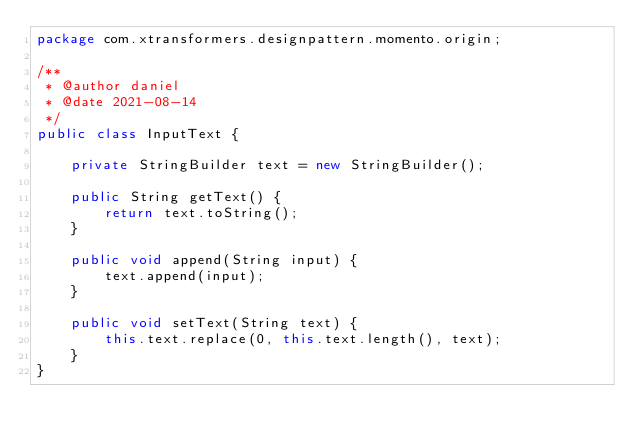Convert code to text. <code><loc_0><loc_0><loc_500><loc_500><_Java_>package com.xtransformers.designpattern.momento.origin;

/**
 * @author daniel
 * @date 2021-08-14
 */
public class InputText {

    private StringBuilder text = new StringBuilder();

    public String getText() {
        return text.toString();
    }

    public void append(String input) {
        text.append(input);
    }

    public void setText(String text) {
        this.text.replace(0, this.text.length(), text);
    }
}
</code> 